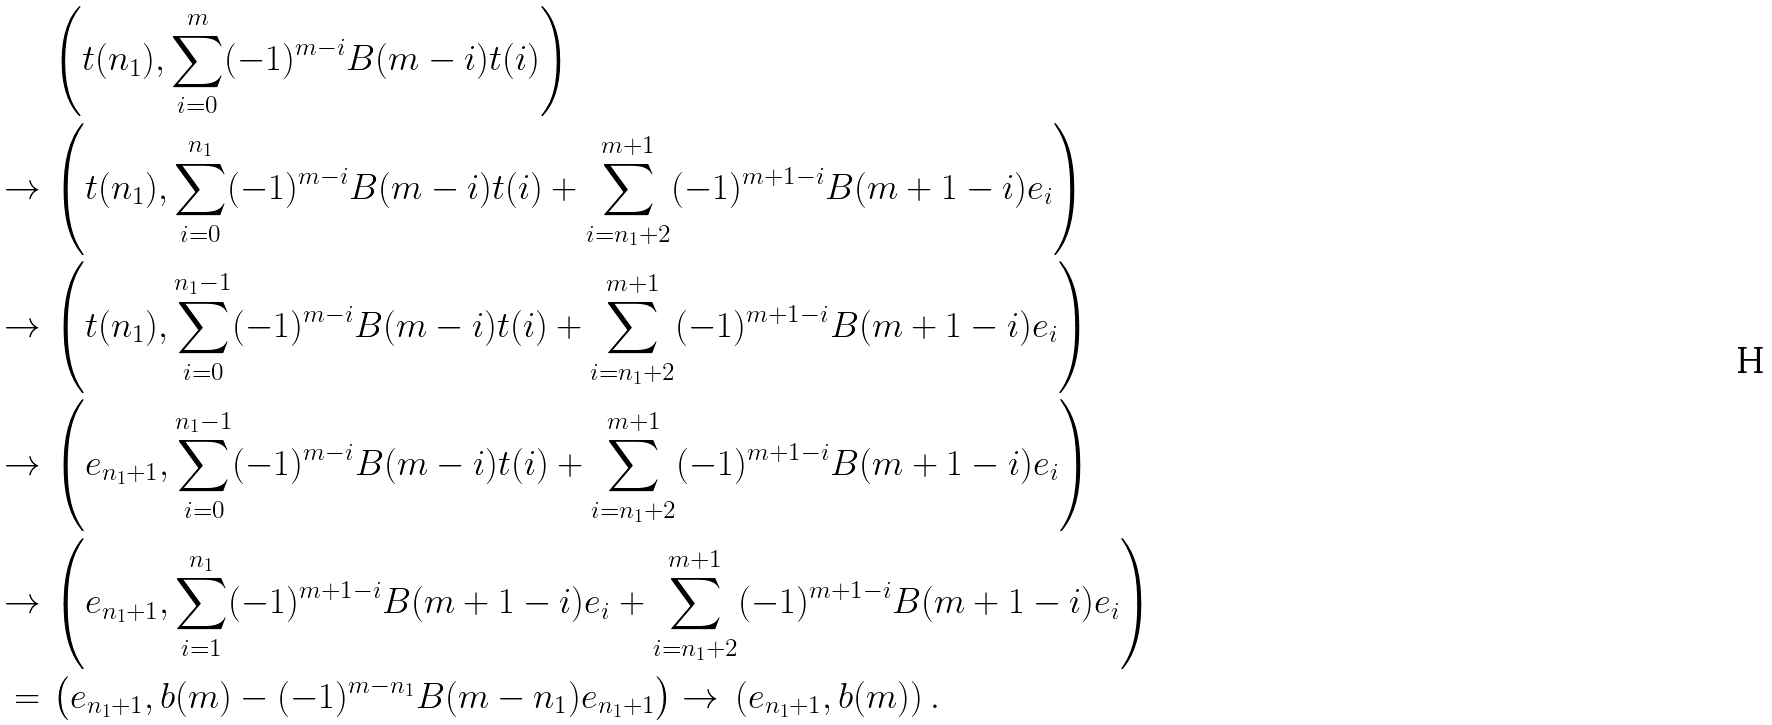<formula> <loc_0><loc_0><loc_500><loc_500>\, & \left ( t ( n _ { 1 } ) , \sum ^ { m } _ { i = 0 } ( - 1 ) ^ { m - i } B ( m - i ) t ( i ) \right ) \\ \to \, & \left ( t ( n _ { 1 } ) , \sum ^ { n _ { 1 } } _ { i = 0 } ( - 1 ) ^ { m - i } B ( m - i ) t ( i ) + \sum ^ { m + 1 } _ { i = n _ { 1 } + 2 } ( - 1 ) ^ { m + 1 - i } B ( m + 1 - i ) e _ { i } \right ) \\ \to \, & \left ( t ( n _ { 1 } ) , \sum ^ { n _ { 1 } - 1 } _ { i = 0 } ( - 1 ) ^ { m - i } B ( m - i ) t ( i ) + \sum ^ { m + 1 } _ { i = n _ { 1 } + 2 } ( - 1 ) ^ { m + 1 - i } B ( m + 1 - i ) e _ { i } \right ) \\ \to \, & \left ( e _ { n _ { 1 } + 1 } , \sum ^ { n _ { 1 } - 1 } _ { i = 0 } ( - 1 ) ^ { m - i } B ( m - i ) t ( i ) + \sum ^ { m + 1 } _ { i = n _ { 1 } + 2 } ( - 1 ) ^ { m + 1 - i } B ( m + 1 - i ) e _ { i } \right ) \\ \to \, & \left ( e _ { n _ { 1 } + 1 } , \sum ^ { n _ { 1 } } _ { i = 1 } ( - 1 ) ^ { m + 1 - i } B ( m + 1 - i ) e _ { i } + \sum ^ { m + 1 } _ { i = n _ { 1 } + 2 } ( - 1 ) ^ { m + 1 - i } B ( m + 1 - i ) e _ { i } \right ) \\ = \, & \left ( e _ { n _ { 1 } + 1 } , b ( m ) - ( - 1 ) ^ { m - n _ { 1 } } B ( m - n _ { 1 } ) e _ { n _ { 1 } + 1 } \right ) \to \, \left ( e _ { n _ { 1 } + 1 } , b ( m ) \right ) .</formula> 